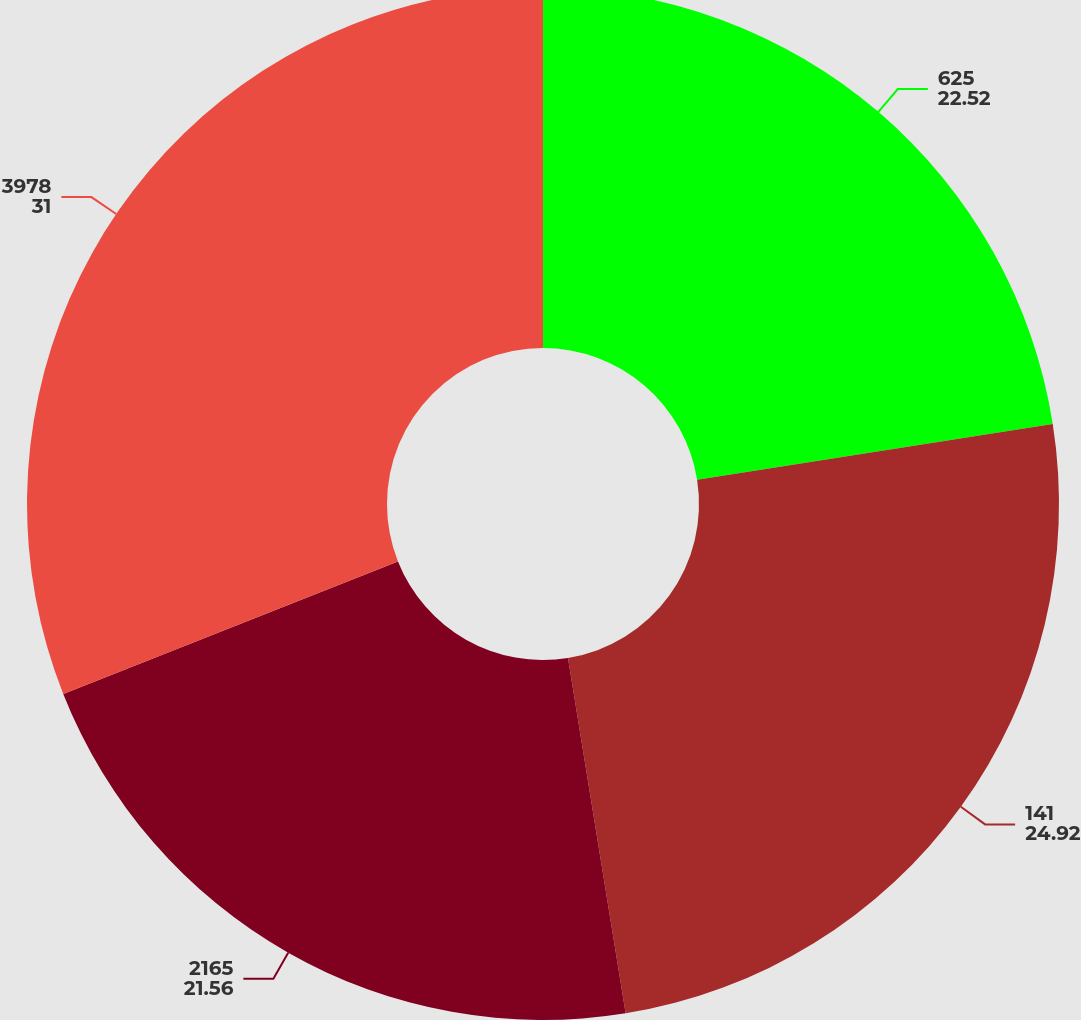Convert chart to OTSL. <chart><loc_0><loc_0><loc_500><loc_500><pie_chart><fcel>625<fcel>141<fcel>2165<fcel>3978<nl><fcel>22.52%<fcel>24.92%<fcel>21.56%<fcel>31.0%<nl></chart> 